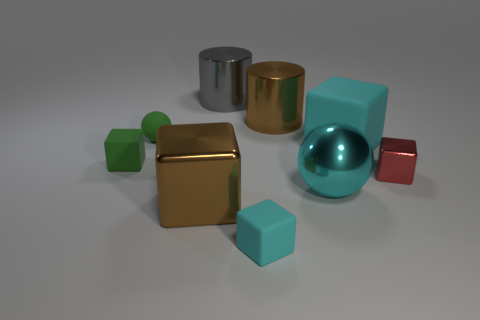How many objects are there in total, and can you describe their shapes? In total, there are seven objects. Starting from the left, there's a small green cube, a tall silver cylinder, a golden cube, an aqua cube, a smaller turquoise cube, a shiny teal sphere, and finally a small red cube. 